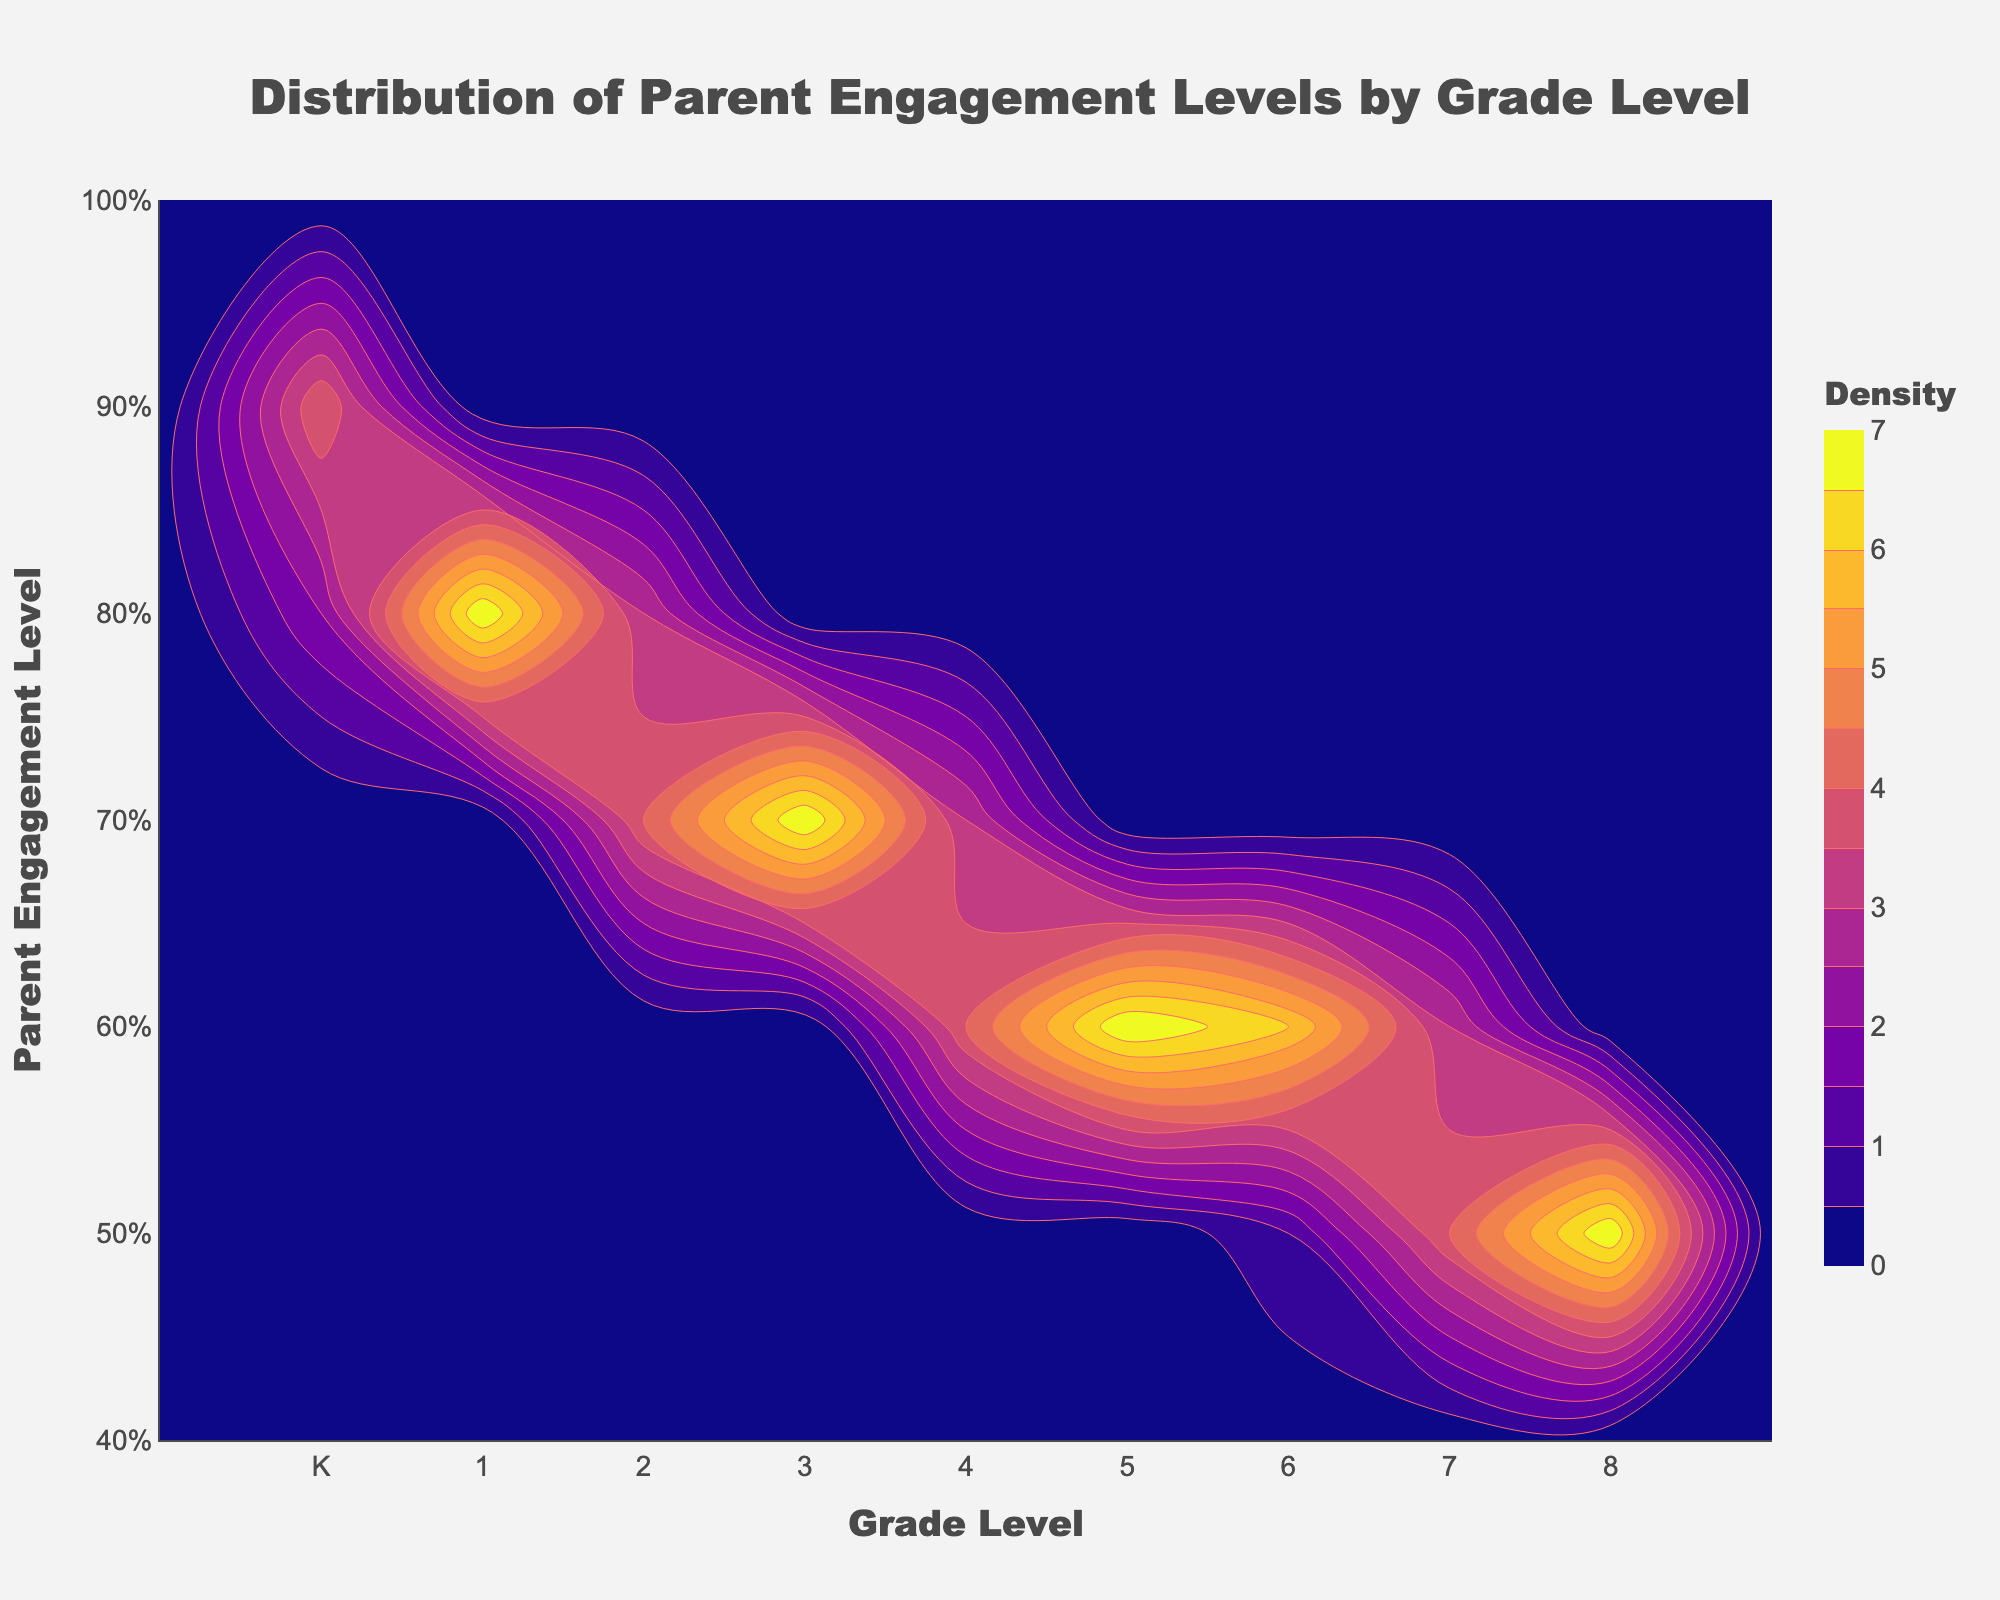What is the title of the plot? The title is at the top of the plot and it provides a summary of what the figure represents. By looking at the figure, you can see the title reads "Distribution of Parent Engagement Levels by Grade Level."
Answer: Distribution of Parent Engagement Levels by Grade Level What are the axes labels? The labels for the axes are present along the horizontal and vertical lines. The x-axis is labeled "Grade Level" which indicates the different grade levels, and the y-axis is labeled "Parent Engagement Level" which indicates the level of engagement from parents.
Answer: Grade Level, Parent Engagement Level In which grade level is parent engagement the highest? Observing the density levels along the y-axis for each grade level, the highest parent engagement level is visible for Kindergarten, with values clustering around 0.85 to 0.90.
Answer: Kindergarten How does parent engagement change from Kindergarten to 8th grade? Following the gradient of densities from left to right (Kindergarten to 8th grade), you can see a general decline in parent engagement levels. Kindergarten starts high around 0.85-0.90, and by 8th grade, it drops to around 0.50.
Answer: Decreases What is the typical parent engagement level for 5th grade? Looking at the contour density specifically for 5th grade, you see the density clustering around approximately 0.60 to 0.63. Therefore, typical engagement levels are around these values.
Answer: Around 0.60 to 0.63 Compare the parent engagement levels between 2nd grade and 6th grade. To compare the densities, observe the contours for both grades. For 2nd grade, parent engagement levels cluster around 0.72 to 0.76, whereas for 6th grade, the engagement levels are around 0.55 to 0.59. This indicates that 2nd grade has higher parent engagement than 6th grade.
Answer: 2nd grade has higher engagement What is the color used to represent density levels? The plot uses a single color with varying shades to represent different density levels. The base color appears as red with shading variations to display density contours.
Answer: Red How does the density plot indicate areas of high parent engagement? Areas of high parent engagement are shown using more concentrated and darker contour lines, indicating a higher density of data points. These areas stand out compared to the lighter, more spread-out contours of low-density areas.
Answer: Concentrated and darker contour lines Are there any grade levels where parent engagement levels overlap significantly? Examining the density overlaps, there seems to be noticeable overlaps between adjacent grades such as 1st and 2nd grades, where the engagement levels are close and the contours intersect significantly.
Answer: 1st and 2nd grades What is the range of parent engagement levels shown on the y-axis? The y-axis has a labeled range starting from 0.4 to 1.0, representing the minimum and maximum parent engagement levels observed in the data.
Answer: 0.4 to 1.0 